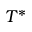<formula> <loc_0><loc_0><loc_500><loc_500>T ^ { * }</formula> 